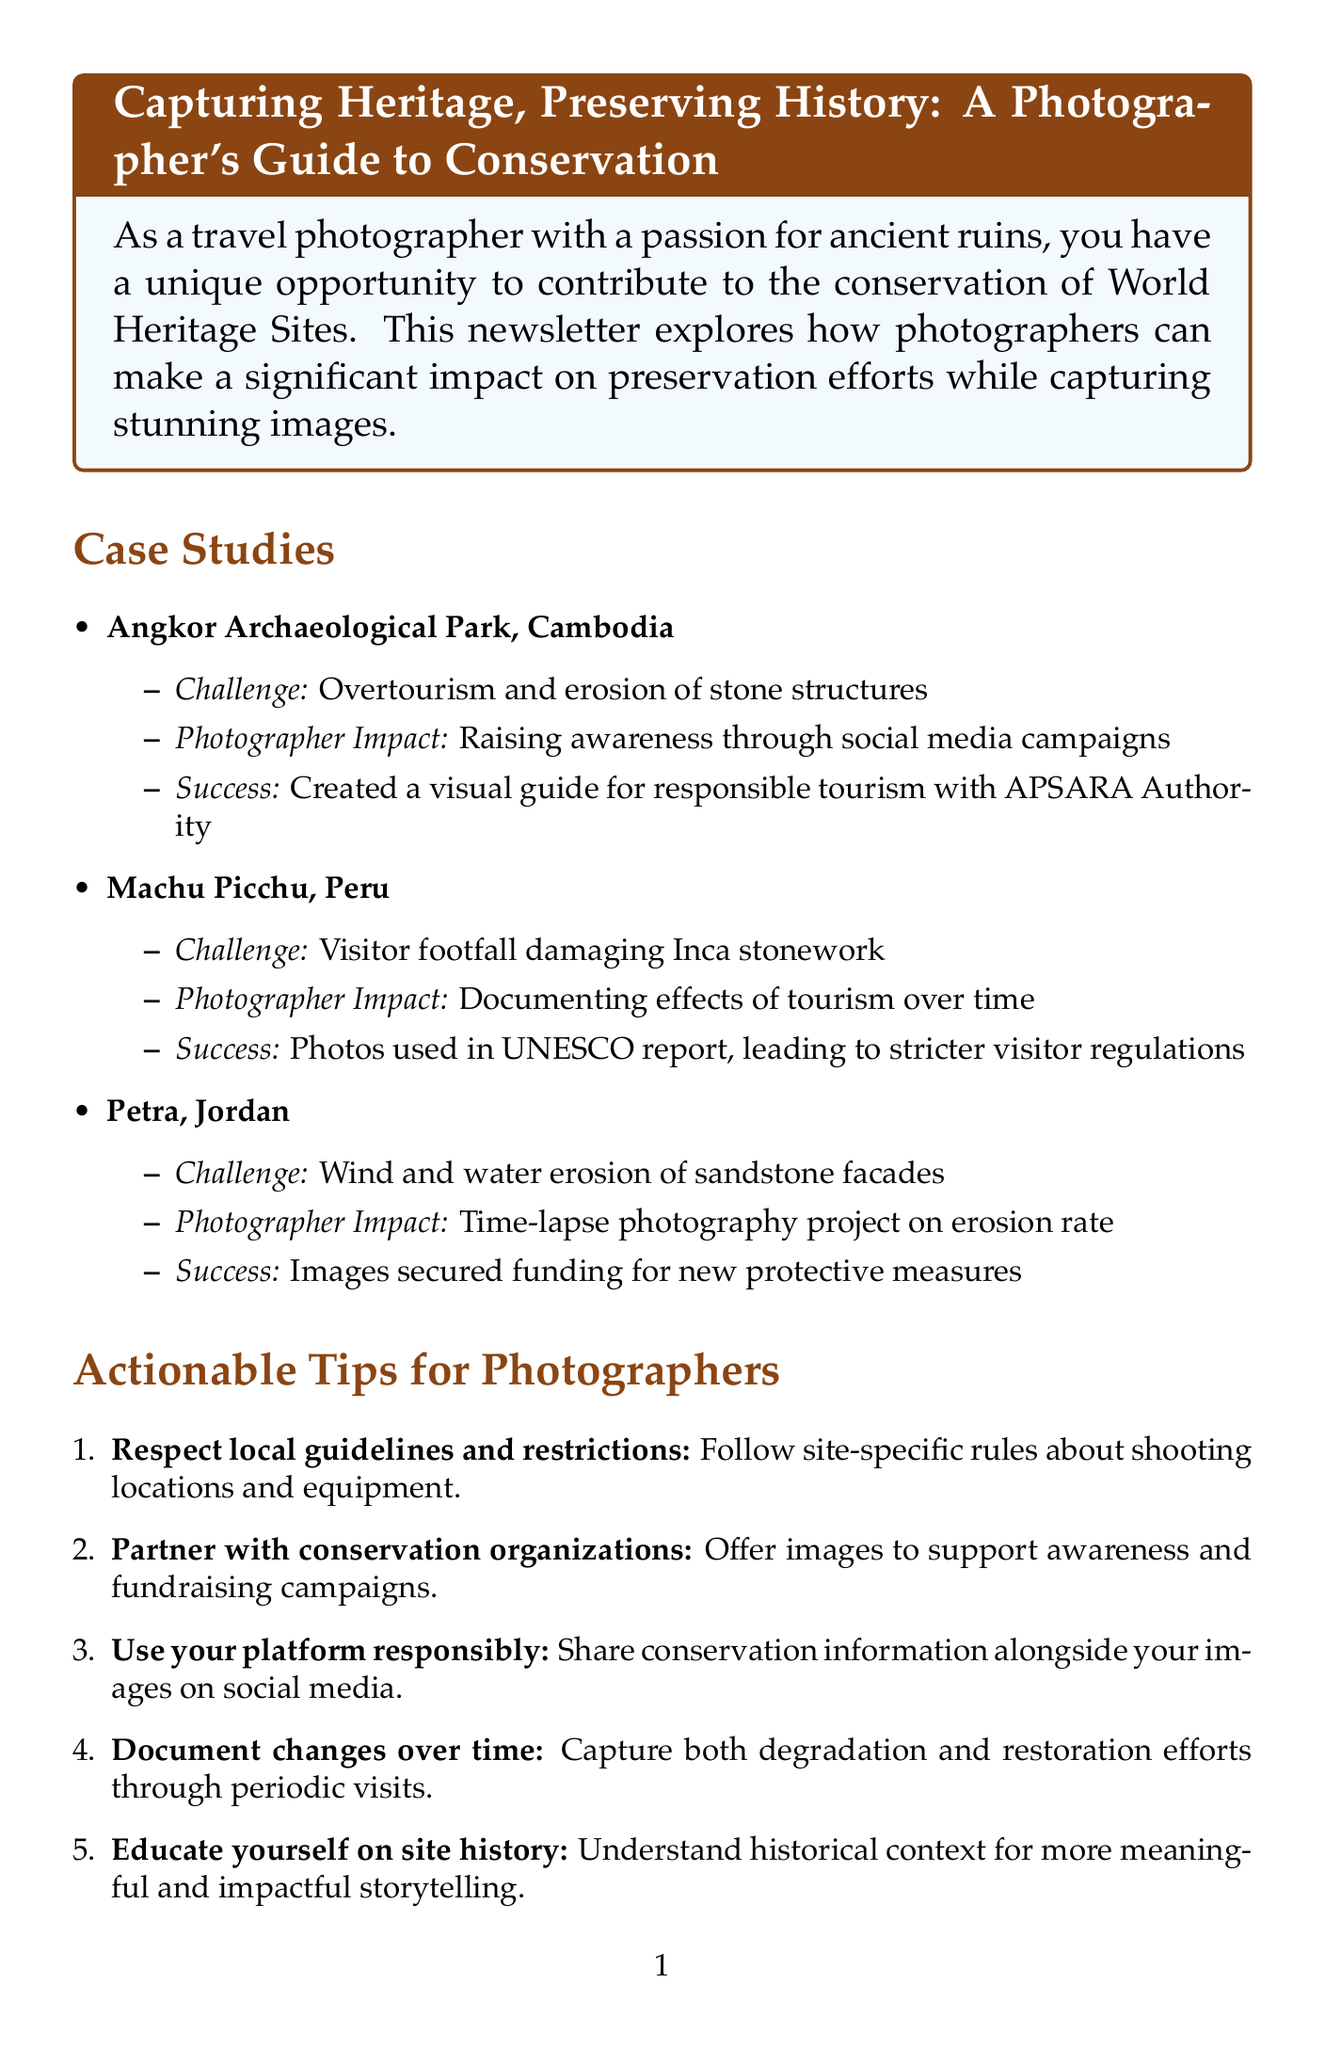What is the title of the newsletter? The title of the newsletter is provided in the document's heading section.
Answer: Capturing Heritage, Preserving History: A Photographer's Guide to Conservation Who collaborated with photographers at Angkor Archaeological Park? The document specifies a partnership that was significant for raising awareness at the site.
Answer: APSARA Authority What challenge does Machu Picchu face? The document outlines specific challenges faced by each World Heritage Site, including Machu Picchu.
Answer: Visitor footfall damaging Inca stonework When will the International Conference on Heritage Photography take place? The date for this specific event is mentioned in the section about upcoming events.
Answer: September 15-17, 2023 What type of photography project was conducted at Petra? The document describes a specific photography initiative aimed at highlighting issues at the site.
Answer: Time-lapse photography project Which tip encourages photographers to share conservation information on social media? The actionable tips section mentions advice related to responsible social media use.
Answer: Use your platform responsibly What gear is recommended for capturing aerial views? The gear recommendations provided in the document specify the best equipment for various photography needs.
Answer: DJI Mavic 3 Pro drone What is the primary role of photographers in conservation according to Dr. Sarah Thompson? The expert insight section provides a quote that summarizes this role.
Answer: Inspire action to protect it 